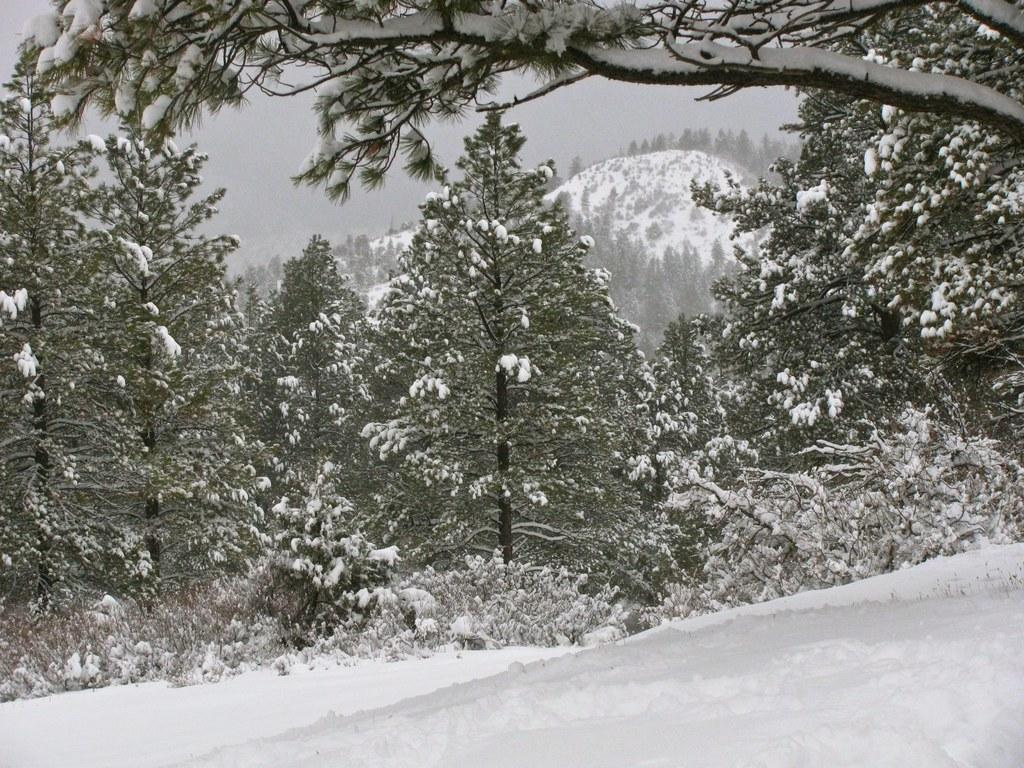What is the predominant weather condition in the image? There is snow in the image, indicating a cold and wintry condition. What type of natural vegetation can be seen in the image? There are trees in the image. What is visible in the background of the image? The sky is visible in the image. What type of iron is being used to cook the pickle in the image? There is no iron or pickle present in the image; it features snow and trees. 